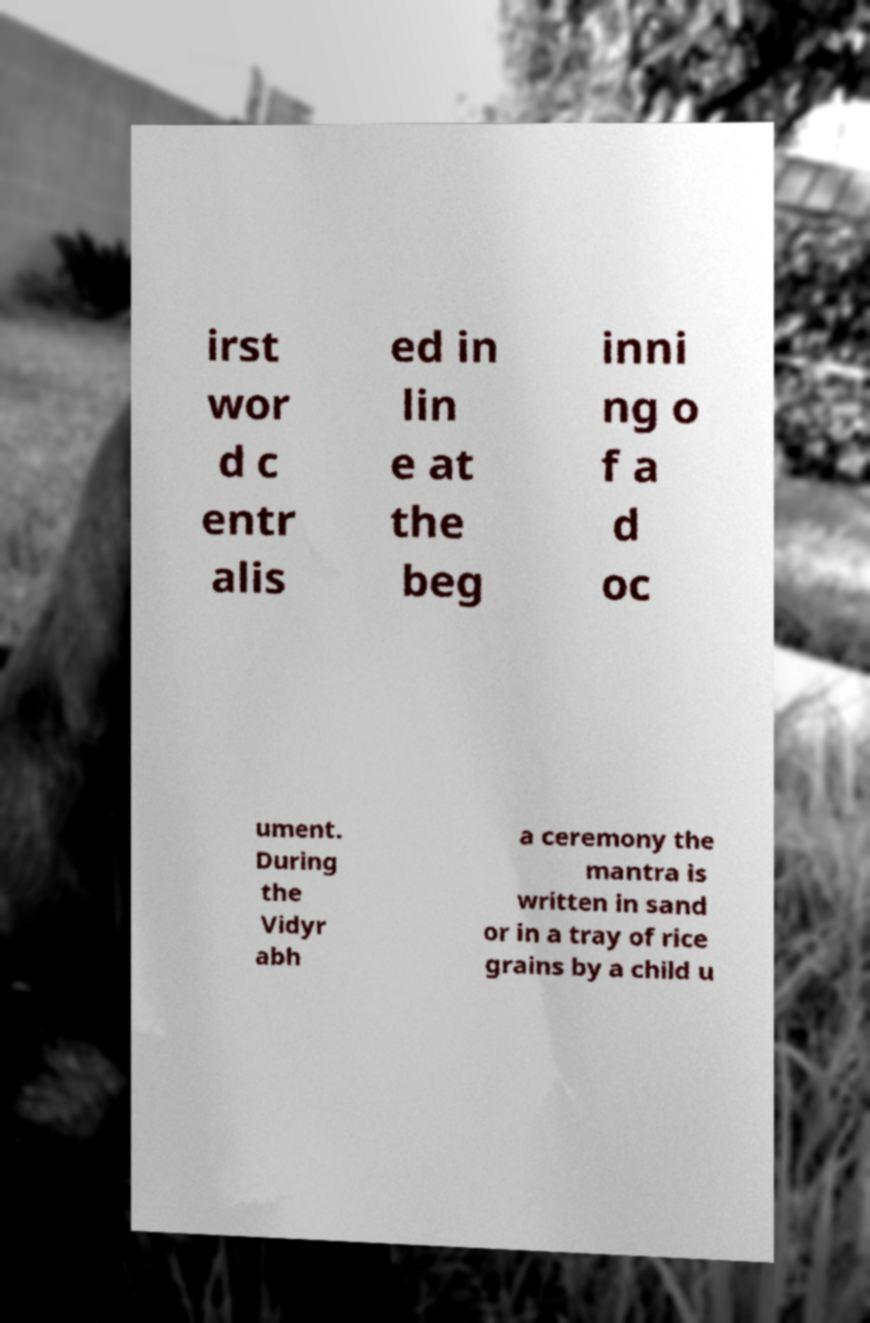Could you assist in decoding the text presented in this image and type it out clearly? irst wor d c entr alis ed in lin e at the beg inni ng o f a d oc ument. During the Vidyr abh a ceremony the mantra is written in sand or in a tray of rice grains by a child u 